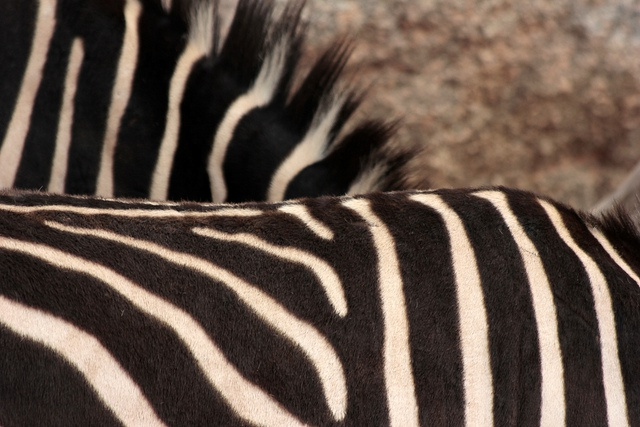Describe the objects in this image and their specific colors. I can see zebra in black, lightgray, and tan tones and zebra in black, gray, and tan tones in this image. 